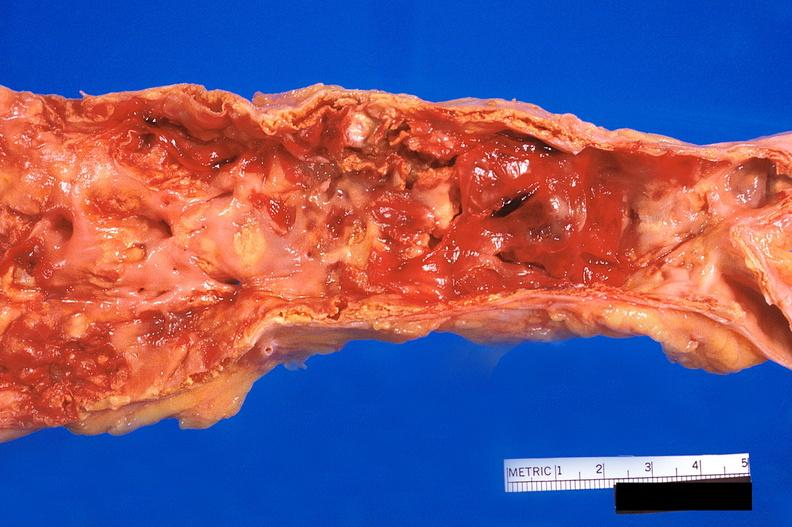what is present?
Answer the question using a single word or phrase. Cardiovascular 